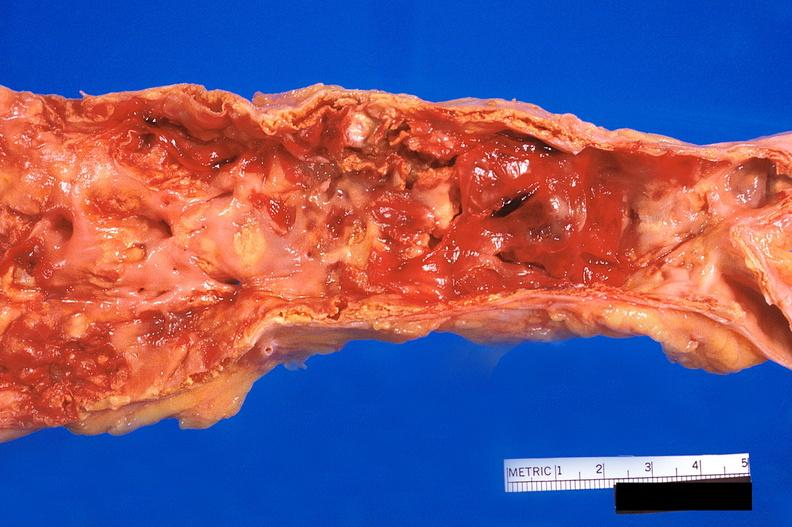what is present?
Answer the question using a single word or phrase. Cardiovascular 